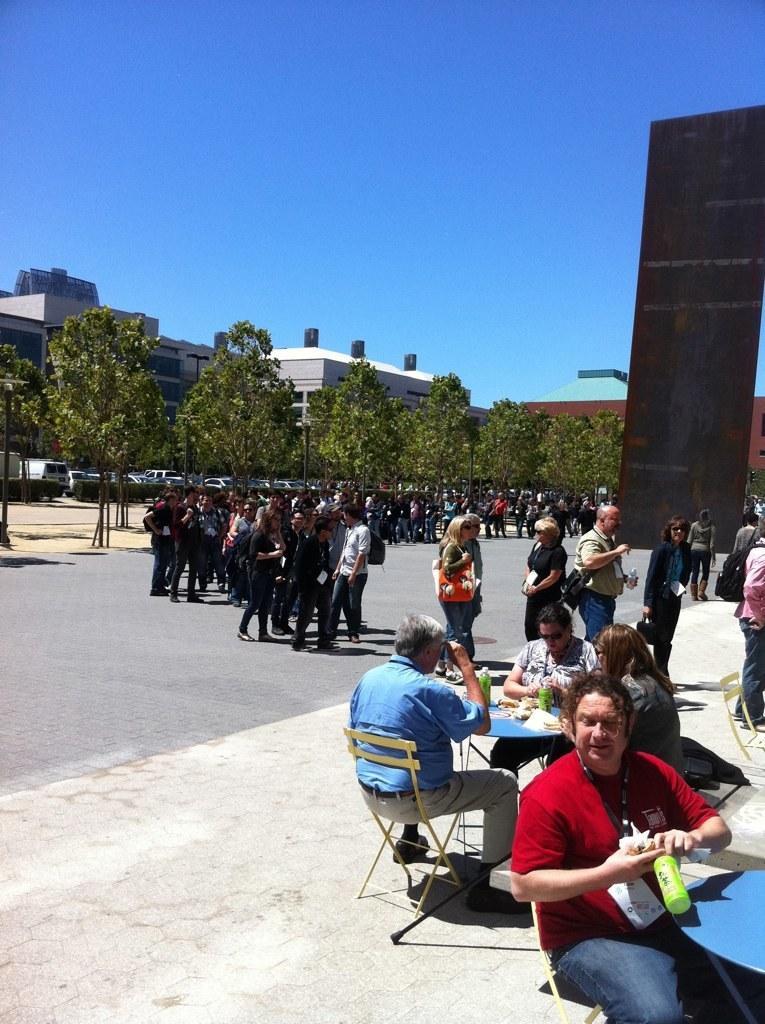Please provide a concise description of this image. Here in this picture, in the front we can see a group of people sitting on chairs with table in front of them having some things on it and beside and beside them on the road we can see number of people standing in groups and we can also see some people are walking on the road and we can also see plants and trees present and we can see vehicles present in the far and we can also see buildings present and we can see the sky is clear and we can see some people are carrying bags with them. 